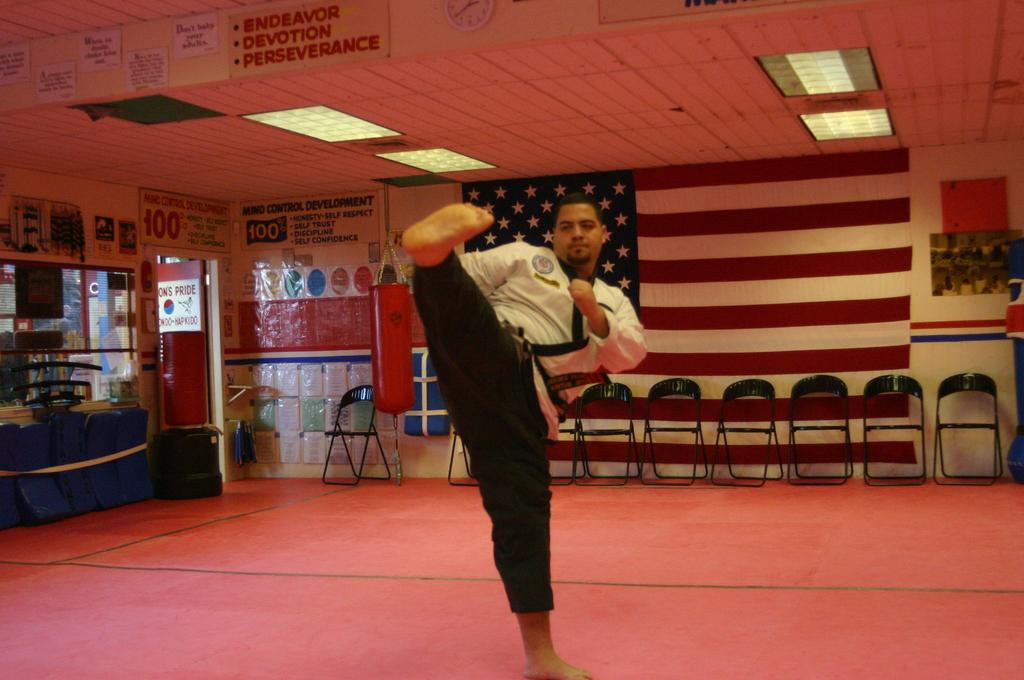<image>
Render a clear and concise summary of the photo. A man performs a kick under a sign that says "endeavor, devotion, perseverance." 